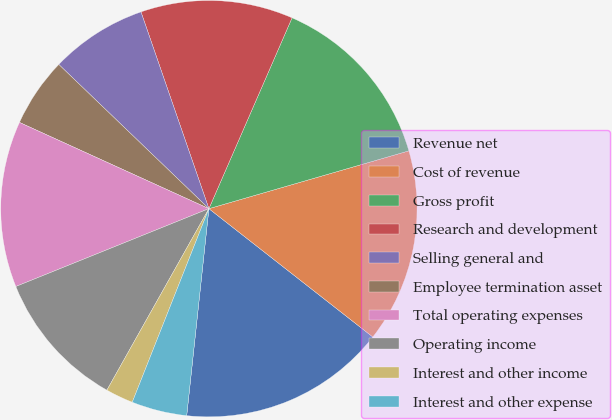<chart> <loc_0><loc_0><loc_500><loc_500><pie_chart><fcel>Revenue net<fcel>Cost of revenue<fcel>Gross profit<fcel>Research and development<fcel>Selling general and<fcel>Employee termination asset<fcel>Total operating expenses<fcel>Operating income<fcel>Interest and other income<fcel>Interest and other expense<nl><fcel>16.13%<fcel>15.05%<fcel>13.98%<fcel>11.83%<fcel>7.53%<fcel>5.38%<fcel>12.9%<fcel>10.75%<fcel>2.15%<fcel>4.3%<nl></chart> 